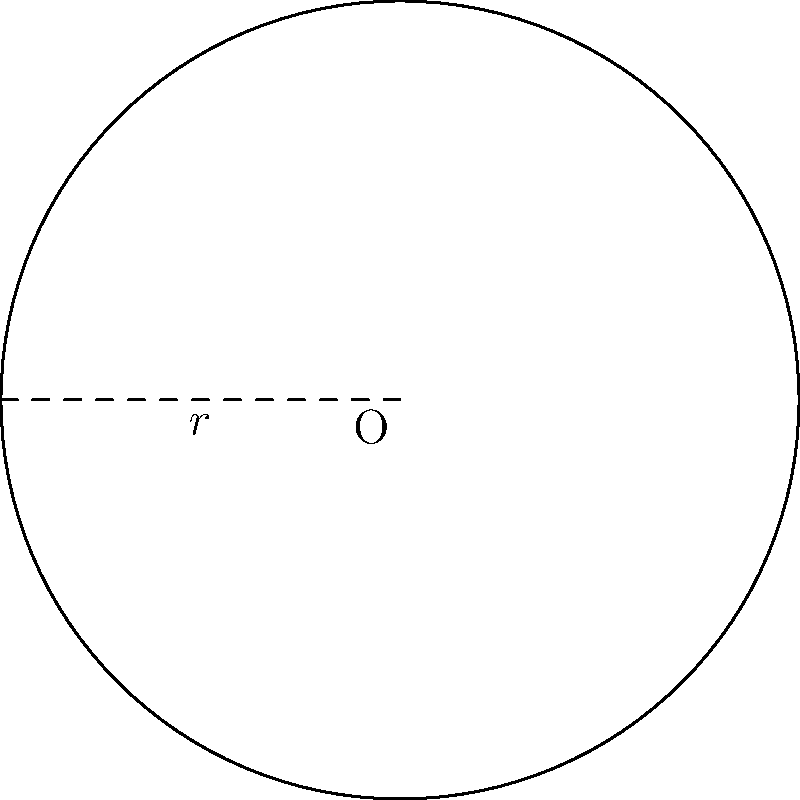You're planning to outdo your rival's outdoor seating area by creating a circular patio. If the radius of your circular patio is 15 feet, what will be the perimeter of the seating area? (Use $\pi \approx 3.14$) To find the perimeter of a circular area, we need to calculate its circumference. The formula for the circumference of a circle is:

$$C = 2\pi r$$

Where:
$C$ = circumference (perimeter)
$\pi$ = pi (approximately 3.14)
$r$ = radius

Given:
$r = 15$ feet
$\pi \approx 3.14$

Let's substitute these values into the formula:

$$C = 2 \times 3.14 \times 15$$

$$C = 94.2$$

Therefore, the perimeter of the circular outdoor seating area is approximately 94.2 feet.
Answer: 94.2 feet 